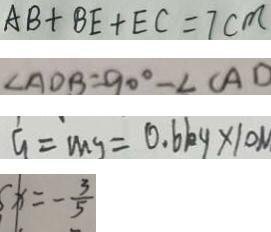<formula> <loc_0><loc_0><loc_500><loc_500>A B + B E + E C = 7 c m 
 \angle A D B = 9 0 ^ { \circ } - \angle C A D 
 G = m g = 0 . 6 k g \times 1 0 N 
 x = - \frac { 3 } { 5 }</formula> 